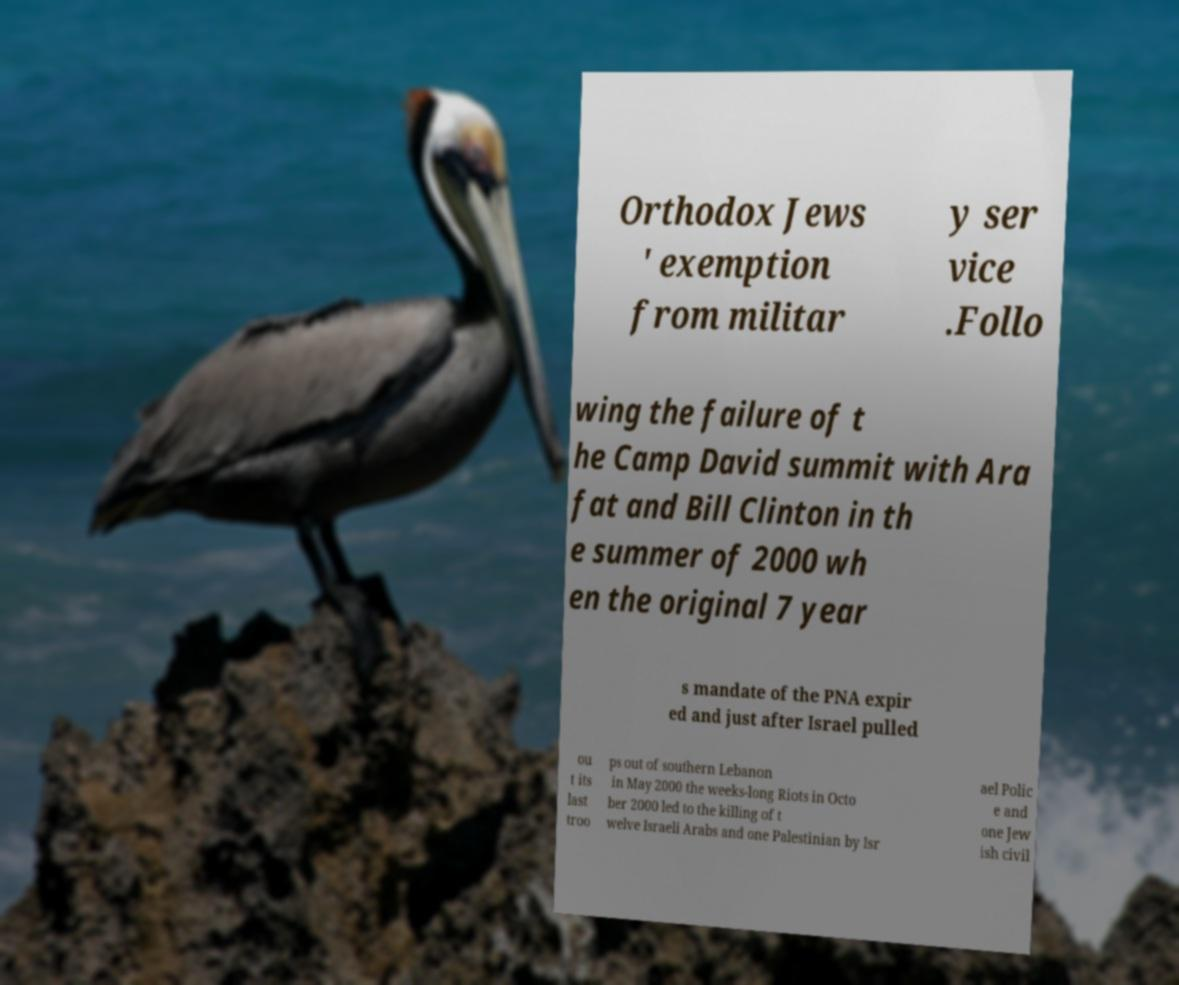Can you accurately transcribe the text from the provided image for me? Orthodox Jews ' exemption from militar y ser vice .Follo wing the failure of t he Camp David summit with Ara fat and Bill Clinton in th e summer of 2000 wh en the original 7 year s mandate of the PNA expir ed and just after Israel pulled ou t its last troo ps out of southern Lebanon in May 2000 the weeks-long Riots in Octo ber 2000 led to the killing of t welve Israeli Arabs and one Palestinian by Isr ael Polic e and one Jew ish civil 